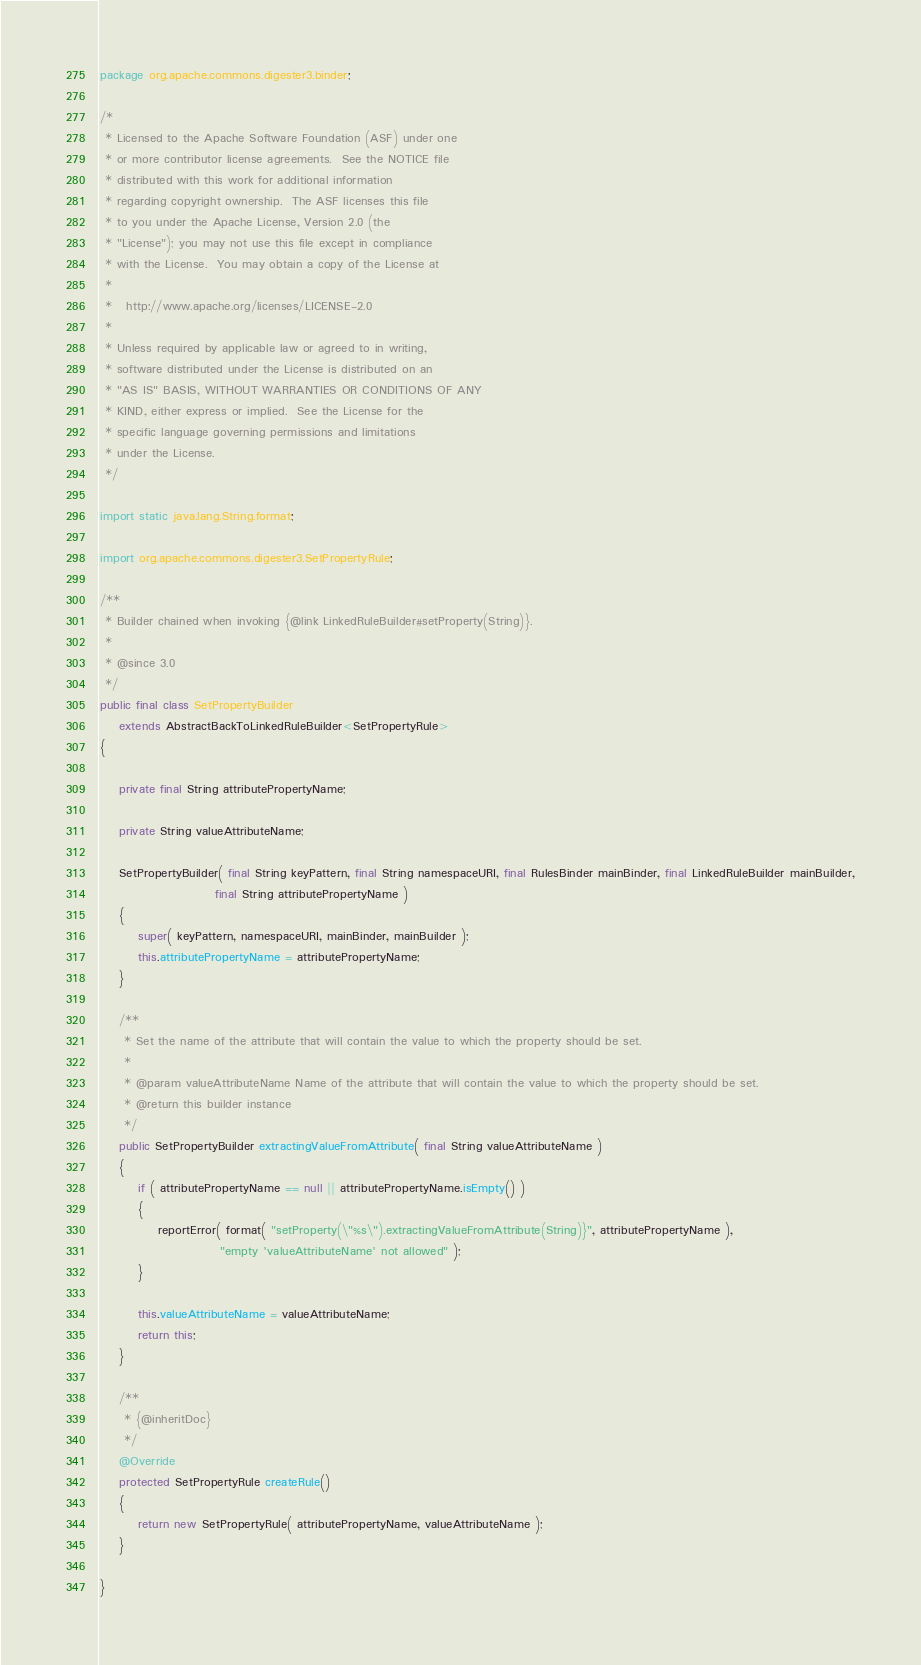Convert code to text. <code><loc_0><loc_0><loc_500><loc_500><_Java_>package org.apache.commons.digester3.binder;

/*
 * Licensed to the Apache Software Foundation (ASF) under one
 * or more contributor license agreements.  See the NOTICE file
 * distributed with this work for additional information
 * regarding copyright ownership.  The ASF licenses this file
 * to you under the Apache License, Version 2.0 (the
 * "License"); you may not use this file except in compliance
 * with the License.  You may obtain a copy of the License at
 *
 *   http://www.apache.org/licenses/LICENSE-2.0
 *
 * Unless required by applicable law or agreed to in writing,
 * software distributed under the License is distributed on an
 * "AS IS" BASIS, WITHOUT WARRANTIES OR CONDITIONS OF ANY
 * KIND, either express or implied.  See the License for the
 * specific language governing permissions and limitations
 * under the License.
 */

import static java.lang.String.format;

import org.apache.commons.digester3.SetPropertyRule;

/**
 * Builder chained when invoking {@link LinkedRuleBuilder#setProperty(String)}.
 *
 * @since 3.0
 */
public final class SetPropertyBuilder
    extends AbstractBackToLinkedRuleBuilder<SetPropertyRule>
{

    private final String attributePropertyName;

    private String valueAttributeName;

    SetPropertyBuilder( final String keyPattern, final String namespaceURI, final RulesBinder mainBinder, final LinkedRuleBuilder mainBuilder,
                        final String attributePropertyName )
    {
        super( keyPattern, namespaceURI, mainBinder, mainBuilder );
        this.attributePropertyName = attributePropertyName;
    }

    /**
     * Set the name of the attribute that will contain the value to which the property should be set.
     *
     * @param valueAttributeName Name of the attribute that will contain the value to which the property should be set.
     * @return this builder instance
     */
    public SetPropertyBuilder extractingValueFromAttribute( final String valueAttributeName )
    {
        if ( attributePropertyName == null || attributePropertyName.isEmpty() )
        {
            reportError( format( "setProperty(\"%s\").extractingValueFromAttribute(String)}", attributePropertyName ),
                         "empty 'valueAttributeName' not allowed" );
        }

        this.valueAttributeName = valueAttributeName;
        return this;
    }

    /**
     * {@inheritDoc}
     */
    @Override
    protected SetPropertyRule createRule()
    {
        return new SetPropertyRule( attributePropertyName, valueAttributeName );
    }

}
</code> 